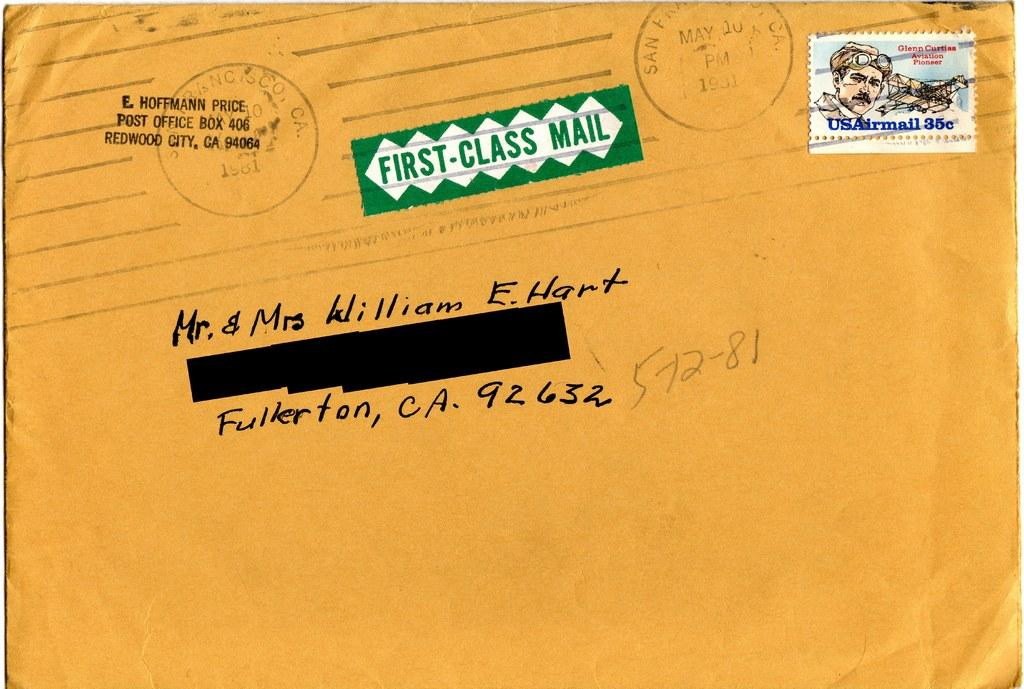<image>
Relay a brief, clear account of the picture shown. The envelope is going to travel  to Fullerton, California. 